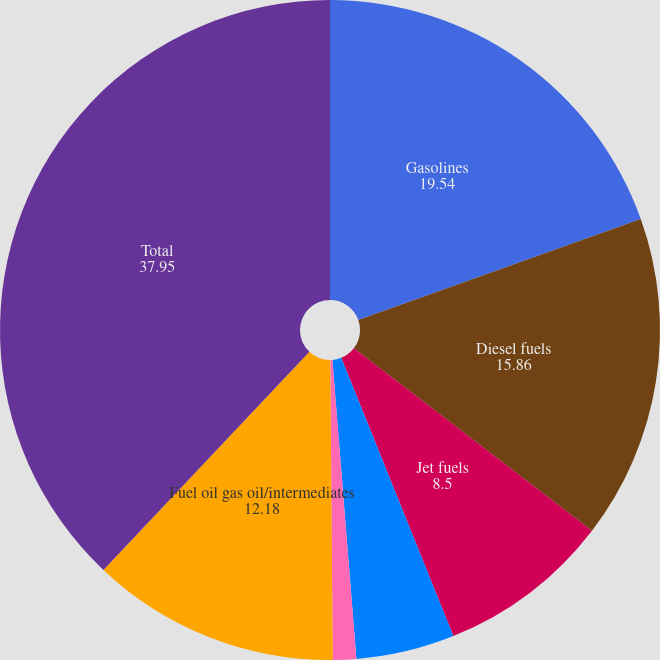Convert chart to OTSL. <chart><loc_0><loc_0><loc_500><loc_500><pie_chart><fcel>Gasolines<fcel>Diesel fuels<fcel>Jet fuels<fcel>Asphalt<fcel>Lubricants<fcel>Fuel oil gas oil/intermediates<fcel>Total<nl><fcel>19.54%<fcel>15.86%<fcel>8.5%<fcel>4.82%<fcel>1.14%<fcel>12.18%<fcel>37.95%<nl></chart> 